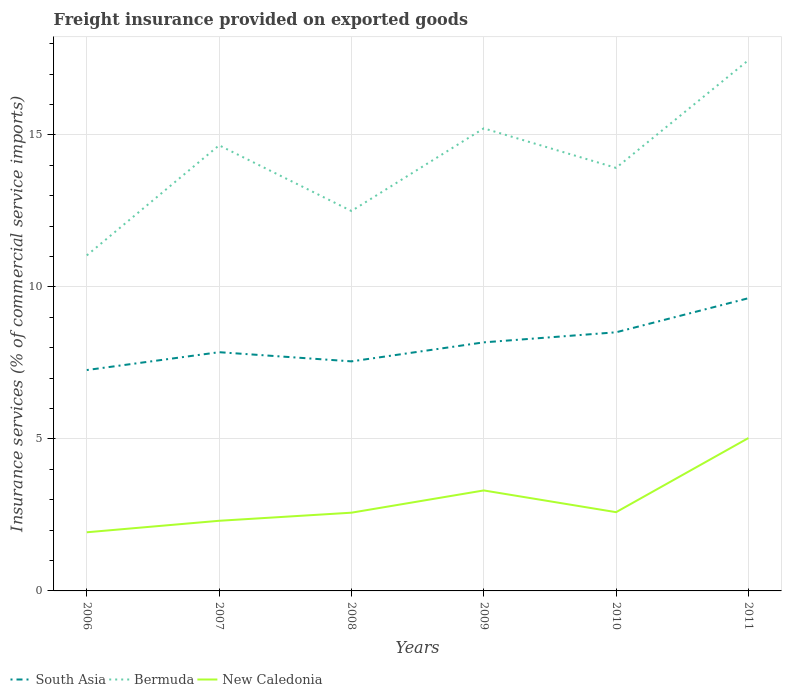Is the number of lines equal to the number of legend labels?
Your response must be concise. Yes. Across all years, what is the maximum freight insurance provided on exported goods in South Asia?
Give a very brief answer. 7.27. What is the total freight insurance provided on exported goods in Bermuda in the graph?
Give a very brief answer. -0.56. What is the difference between the highest and the second highest freight insurance provided on exported goods in South Asia?
Your response must be concise. 2.36. What is the difference between the highest and the lowest freight insurance provided on exported goods in New Caledonia?
Offer a terse response. 2. How many lines are there?
Ensure brevity in your answer.  3. What is the difference between two consecutive major ticks on the Y-axis?
Make the answer very short. 5. What is the title of the graph?
Offer a very short reply. Freight insurance provided on exported goods. Does "Turks and Caicos Islands" appear as one of the legend labels in the graph?
Ensure brevity in your answer.  No. What is the label or title of the X-axis?
Keep it short and to the point. Years. What is the label or title of the Y-axis?
Provide a short and direct response. Insurance services (% of commercial service imports). What is the Insurance services (% of commercial service imports) in South Asia in 2006?
Provide a succinct answer. 7.27. What is the Insurance services (% of commercial service imports) of Bermuda in 2006?
Your answer should be compact. 11.04. What is the Insurance services (% of commercial service imports) in New Caledonia in 2006?
Offer a terse response. 1.93. What is the Insurance services (% of commercial service imports) of South Asia in 2007?
Give a very brief answer. 7.85. What is the Insurance services (% of commercial service imports) of Bermuda in 2007?
Provide a succinct answer. 14.66. What is the Insurance services (% of commercial service imports) in New Caledonia in 2007?
Ensure brevity in your answer.  2.31. What is the Insurance services (% of commercial service imports) of South Asia in 2008?
Offer a terse response. 7.55. What is the Insurance services (% of commercial service imports) in Bermuda in 2008?
Provide a succinct answer. 12.5. What is the Insurance services (% of commercial service imports) of New Caledonia in 2008?
Your answer should be compact. 2.57. What is the Insurance services (% of commercial service imports) in South Asia in 2009?
Offer a terse response. 8.18. What is the Insurance services (% of commercial service imports) of Bermuda in 2009?
Ensure brevity in your answer.  15.22. What is the Insurance services (% of commercial service imports) of New Caledonia in 2009?
Ensure brevity in your answer.  3.31. What is the Insurance services (% of commercial service imports) of South Asia in 2010?
Provide a short and direct response. 8.51. What is the Insurance services (% of commercial service imports) in Bermuda in 2010?
Your answer should be compact. 13.91. What is the Insurance services (% of commercial service imports) in New Caledonia in 2010?
Offer a very short reply. 2.59. What is the Insurance services (% of commercial service imports) in South Asia in 2011?
Provide a short and direct response. 9.63. What is the Insurance services (% of commercial service imports) of Bermuda in 2011?
Your response must be concise. 17.46. What is the Insurance services (% of commercial service imports) of New Caledonia in 2011?
Provide a succinct answer. 5.03. Across all years, what is the maximum Insurance services (% of commercial service imports) in South Asia?
Your response must be concise. 9.63. Across all years, what is the maximum Insurance services (% of commercial service imports) in Bermuda?
Your answer should be very brief. 17.46. Across all years, what is the maximum Insurance services (% of commercial service imports) in New Caledonia?
Your answer should be compact. 5.03. Across all years, what is the minimum Insurance services (% of commercial service imports) in South Asia?
Offer a terse response. 7.27. Across all years, what is the minimum Insurance services (% of commercial service imports) of Bermuda?
Make the answer very short. 11.04. Across all years, what is the minimum Insurance services (% of commercial service imports) in New Caledonia?
Your answer should be very brief. 1.93. What is the total Insurance services (% of commercial service imports) in South Asia in the graph?
Provide a succinct answer. 48.98. What is the total Insurance services (% of commercial service imports) in Bermuda in the graph?
Your answer should be very brief. 84.78. What is the total Insurance services (% of commercial service imports) in New Caledonia in the graph?
Your answer should be very brief. 17.73. What is the difference between the Insurance services (% of commercial service imports) in South Asia in 2006 and that in 2007?
Your answer should be compact. -0.59. What is the difference between the Insurance services (% of commercial service imports) of Bermuda in 2006 and that in 2007?
Your answer should be very brief. -3.62. What is the difference between the Insurance services (% of commercial service imports) of New Caledonia in 2006 and that in 2007?
Your answer should be compact. -0.38. What is the difference between the Insurance services (% of commercial service imports) in South Asia in 2006 and that in 2008?
Your answer should be very brief. -0.29. What is the difference between the Insurance services (% of commercial service imports) of Bermuda in 2006 and that in 2008?
Your response must be concise. -1.46. What is the difference between the Insurance services (% of commercial service imports) in New Caledonia in 2006 and that in 2008?
Give a very brief answer. -0.64. What is the difference between the Insurance services (% of commercial service imports) in South Asia in 2006 and that in 2009?
Keep it short and to the point. -0.91. What is the difference between the Insurance services (% of commercial service imports) in Bermuda in 2006 and that in 2009?
Give a very brief answer. -4.18. What is the difference between the Insurance services (% of commercial service imports) of New Caledonia in 2006 and that in 2009?
Provide a succinct answer. -1.38. What is the difference between the Insurance services (% of commercial service imports) of South Asia in 2006 and that in 2010?
Offer a terse response. -1.24. What is the difference between the Insurance services (% of commercial service imports) in Bermuda in 2006 and that in 2010?
Your response must be concise. -2.88. What is the difference between the Insurance services (% of commercial service imports) of New Caledonia in 2006 and that in 2010?
Offer a terse response. -0.66. What is the difference between the Insurance services (% of commercial service imports) of South Asia in 2006 and that in 2011?
Your answer should be compact. -2.36. What is the difference between the Insurance services (% of commercial service imports) of Bermuda in 2006 and that in 2011?
Ensure brevity in your answer.  -6.42. What is the difference between the Insurance services (% of commercial service imports) of New Caledonia in 2006 and that in 2011?
Make the answer very short. -3.1. What is the difference between the Insurance services (% of commercial service imports) in South Asia in 2007 and that in 2008?
Provide a short and direct response. 0.3. What is the difference between the Insurance services (% of commercial service imports) in Bermuda in 2007 and that in 2008?
Give a very brief answer. 2.16. What is the difference between the Insurance services (% of commercial service imports) of New Caledonia in 2007 and that in 2008?
Give a very brief answer. -0.27. What is the difference between the Insurance services (% of commercial service imports) of South Asia in 2007 and that in 2009?
Give a very brief answer. -0.32. What is the difference between the Insurance services (% of commercial service imports) in Bermuda in 2007 and that in 2009?
Keep it short and to the point. -0.56. What is the difference between the Insurance services (% of commercial service imports) of New Caledonia in 2007 and that in 2009?
Your answer should be compact. -1. What is the difference between the Insurance services (% of commercial service imports) in South Asia in 2007 and that in 2010?
Offer a terse response. -0.66. What is the difference between the Insurance services (% of commercial service imports) of Bermuda in 2007 and that in 2010?
Ensure brevity in your answer.  0.74. What is the difference between the Insurance services (% of commercial service imports) of New Caledonia in 2007 and that in 2010?
Provide a succinct answer. -0.28. What is the difference between the Insurance services (% of commercial service imports) of South Asia in 2007 and that in 2011?
Make the answer very short. -1.78. What is the difference between the Insurance services (% of commercial service imports) of New Caledonia in 2007 and that in 2011?
Provide a short and direct response. -2.72. What is the difference between the Insurance services (% of commercial service imports) in South Asia in 2008 and that in 2009?
Offer a very short reply. -0.63. What is the difference between the Insurance services (% of commercial service imports) of Bermuda in 2008 and that in 2009?
Give a very brief answer. -2.72. What is the difference between the Insurance services (% of commercial service imports) in New Caledonia in 2008 and that in 2009?
Provide a succinct answer. -0.73. What is the difference between the Insurance services (% of commercial service imports) in South Asia in 2008 and that in 2010?
Your response must be concise. -0.96. What is the difference between the Insurance services (% of commercial service imports) of Bermuda in 2008 and that in 2010?
Provide a succinct answer. -1.42. What is the difference between the Insurance services (% of commercial service imports) of New Caledonia in 2008 and that in 2010?
Give a very brief answer. -0.02. What is the difference between the Insurance services (% of commercial service imports) of South Asia in 2008 and that in 2011?
Offer a terse response. -2.08. What is the difference between the Insurance services (% of commercial service imports) of Bermuda in 2008 and that in 2011?
Your answer should be compact. -4.96. What is the difference between the Insurance services (% of commercial service imports) in New Caledonia in 2008 and that in 2011?
Offer a very short reply. -2.46. What is the difference between the Insurance services (% of commercial service imports) of South Asia in 2009 and that in 2010?
Offer a very short reply. -0.33. What is the difference between the Insurance services (% of commercial service imports) in Bermuda in 2009 and that in 2010?
Your answer should be very brief. 1.3. What is the difference between the Insurance services (% of commercial service imports) of New Caledonia in 2009 and that in 2010?
Offer a terse response. 0.71. What is the difference between the Insurance services (% of commercial service imports) of South Asia in 2009 and that in 2011?
Your answer should be compact. -1.45. What is the difference between the Insurance services (% of commercial service imports) of Bermuda in 2009 and that in 2011?
Provide a succinct answer. -2.24. What is the difference between the Insurance services (% of commercial service imports) in New Caledonia in 2009 and that in 2011?
Your answer should be compact. -1.72. What is the difference between the Insurance services (% of commercial service imports) in South Asia in 2010 and that in 2011?
Provide a succinct answer. -1.12. What is the difference between the Insurance services (% of commercial service imports) of Bermuda in 2010 and that in 2011?
Offer a terse response. -3.54. What is the difference between the Insurance services (% of commercial service imports) of New Caledonia in 2010 and that in 2011?
Provide a short and direct response. -2.44. What is the difference between the Insurance services (% of commercial service imports) in South Asia in 2006 and the Insurance services (% of commercial service imports) in Bermuda in 2007?
Your answer should be compact. -7.39. What is the difference between the Insurance services (% of commercial service imports) of South Asia in 2006 and the Insurance services (% of commercial service imports) of New Caledonia in 2007?
Make the answer very short. 4.96. What is the difference between the Insurance services (% of commercial service imports) of Bermuda in 2006 and the Insurance services (% of commercial service imports) of New Caledonia in 2007?
Provide a succinct answer. 8.73. What is the difference between the Insurance services (% of commercial service imports) of South Asia in 2006 and the Insurance services (% of commercial service imports) of Bermuda in 2008?
Give a very brief answer. -5.23. What is the difference between the Insurance services (% of commercial service imports) of South Asia in 2006 and the Insurance services (% of commercial service imports) of New Caledonia in 2008?
Your answer should be compact. 4.69. What is the difference between the Insurance services (% of commercial service imports) of Bermuda in 2006 and the Insurance services (% of commercial service imports) of New Caledonia in 2008?
Give a very brief answer. 8.46. What is the difference between the Insurance services (% of commercial service imports) in South Asia in 2006 and the Insurance services (% of commercial service imports) in Bermuda in 2009?
Make the answer very short. -7.95. What is the difference between the Insurance services (% of commercial service imports) in South Asia in 2006 and the Insurance services (% of commercial service imports) in New Caledonia in 2009?
Your answer should be very brief. 3.96. What is the difference between the Insurance services (% of commercial service imports) in Bermuda in 2006 and the Insurance services (% of commercial service imports) in New Caledonia in 2009?
Your answer should be compact. 7.73. What is the difference between the Insurance services (% of commercial service imports) of South Asia in 2006 and the Insurance services (% of commercial service imports) of Bermuda in 2010?
Your answer should be compact. -6.65. What is the difference between the Insurance services (% of commercial service imports) in South Asia in 2006 and the Insurance services (% of commercial service imports) in New Caledonia in 2010?
Offer a terse response. 4.68. What is the difference between the Insurance services (% of commercial service imports) in Bermuda in 2006 and the Insurance services (% of commercial service imports) in New Caledonia in 2010?
Ensure brevity in your answer.  8.45. What is the difference between the Insurance services (% of commercial service imports) in South Asia in 2006 and the Insurance services (% of commercial service imports) in Bermuda in 2011?
Provide a short and direct response. -10.19. What is the difference between the Insurance services (% of commercial service imports) of South Asia in 2006 and the Insurance services (% of commercial service imports) of New Caledonia in 2011?
Provide a succinct answer. 2.24. What is the difference between the Insurance services (% of commercial service imports) in Bermuda in 2006 and the Insurance services (% of commercial service imports) in New Caledonia in 2011?
Make the answer very short. 6.01. What is the difference between the Insurance services (% of commercial service imports) of South Asia in 2007 and the Insurance services (% of commercial service imports) of Bermuda in 2008?
Provide a short and direct response. -4.64. What is the difference between the Insurance services (% of commercial service imports) of South Asia in 2007 and the Insurance services (% of commercial service imports) of New Caledonia in 2008?
Your answer should be very brief. 5.28. What is the difference between the Insurance services (% of commercial service imports) in Bermuda in 2007 and the Insurance services (% of commercial service imports) in New Caledonia in 2008?
Provide a short and direct response. 12.08. What is the difference between the Insurance services (% of commercial service imports) in South Asia in 2007 and the Insurance services (% of commercial service imports) in Bermuda in 2009?
Make the answer very short. -7.36. What is the difference between the Insurance services (% of commercial service imports) of South Asia in 2007 and the Insurance services (% of commercial service imports) of New Caledonia in 2009?
Your answer should be compact. 4.55. What is the difference between the Insurance services (% of commercial service imports) of Bermuda in 2007 and the Insurance services (% of commercial service imports) of New Caledonia in 2009?
Provide a succinct answer. 11.35. What is the difference between the Insurance services (% of commercial service imports) of South Asia in 2007 and the Insurance services (% of commercial service imports) of Bermuda in 2010?
Keep it short and to the point. -6.06. What is the difference between the Insurance services (% of commercial service imports) of South Asia in 2007 and the Insurance services (% of commercial service imports) of New Caledonia in 2010?
Offer a terse response. 5.26. What is the difference between the Insurance services (% of commercial service imports) of Bermuda in 2007 and the Insurance services (% of commercial service imports) of New Caledonia in 2010?
Keep it short and to the point. 12.07. What is the difference between the Insurance services (% of commercial service imports) of South Asia in 2007 and the Insurance services (% of commercial service imports) of Bermuda in 2011?
Your answer should be compact. -9.61. What is the difference between the Insurance services (% of commercial service imports) of South Asia in 2007 and the Insurance services (% of commercial service imports) of New Caledonia in 2011?
Offer a terse response. 2.82. What is the difference between the Insurance services (% of commercial service imports) of Bermuda in 2007 and the Insurance services (% of commercial service imports) of New Caledonia in 2011?
Your answer should be compact. 9.63. What is the difference between the Insurance services (% of commercial service imports) of South Asia in 2008 and the Insurance services (% of commercial service imports) of Bermuda in 2009?
Offer a terse response. -7.66. What is the difference between the Insurance services (% of commercial service imports) in South Asia in 2008 and the Insurance services (% of commercial service imports) in New Caledonia in 2009?
Give a very brief answer. 4.25. What is the difference between the Insurance services (% of commercial service imports) in Bermuda in 2008 and the Insurance services (% of commercial service imports) in New Caledonia in 2009?
Your answer should be very brief. 9.19. What is the difference between the Insurance services (% of commercial service imports) of South Asia in 2008 and the Insurance services (% of commercial service imports) of Bermuda in 2010?
Ensure brevity in your answer.  -6.36. What is the difference between the Insurance services (% of commercial service imports) of South Asia in 2008 and the Insurance services (% of commercial service imports) of New Caledonia in 2010?
Your response must be concise. 4.96. What is the difference between the Insurance services (% of commercial service imports) in Bermuda in 2008 and the Insurance services (% of commercial service imports) in New Caledonia in 2010?
Offer a very short reply. 9.91. What is the difference between the Insurance services (% of commercial service imports) in South Asia in 2008 and the Insurance services (% of commercial service imports) in Bermuda in 2011?
Give a very brief answer. -9.91. What is the difference between the Insurance services (% of commercial service imports) of South Asia in 2008 and the Insurance services (% of commercial service imports) of New Caledonia in 2011?
Your answer should be compact. 2.52. What is the difference between the Insurance services (% of commercial service imports) of Bermuda in 2008 and the Insurance services (% of commercial service imports) of New Caledonia in 2011?
Give a very brief answer. 7.47. What is the difference between the Insurance services (% of commercial service imports) of South Asia in 2009 and the Insurance services (% of commercial service imports) of Bermuda in 2010?
Your answer should be compact. -5.74. What is the difference between the Insurance services (% of commercial service imports) in South Asia in 2009 and the Insurance services (% of commercial service imports) in New Caledonia in 2010?
Ensure brevity in your answer.  5.59. What is the difference between the Insurance services (% of commercial service imports) in Bermuda in 2009 and the Insurance services (% of commercial service imports) in New Caledonia in 2010?
Offer a very short reply. 12.63. What is the difference between the Insurance services (% of commercial service imports) of South Asia in 2009 and the Insurance services (% of commercial service imports) of Bermuda in 2011?
Your response must be concise. -9.28. What is the difference between the Insurance services (% of commercial service imports) of South Asia in 2009 and the Insurance services (% of commercial service imports) of New Caledonia in 2011?
Provide a short and direct response. 3.15. What is the difference between the Insurance services (% of commercial service imports) in Bermuda in 2009 and the Insurance services (% of commercial service imports) in New Caledonia in 2011?
Give a very brief answer. 10.19. What is the difference between the Insurance services (% of commercial service imports) of South Asia in 2010 and the Insurance services (% of commercial service imports) of Bermuda in 2011?
Provide a short and direct response. -8.95. What is the difference between the Insurance services (% of commercial service imports) of South Asia in 2010 and the Insurance services (% of commercial service imports) of New Caledonia in 2011?
Offer a terse response. 3.48. What is the difference between the Insurance services (% of commercial service imports) in Bermuda in 2010 and the Insurance services (% of commercial service imports) in New Caledonia in 2011?
Provide a succinct answer. 8.89. What is the average Insurance services (% of commercial service imports) in South Asia per year?
Provide a succinct answer. 8.16. What is the average Insurance services (% of commercial service imports) in Bermuda per year?
Ensure brevity in your answer.  14.13. What is the average Insurance services (% of commercial service imports) of New Caledonia per year?
Make the answer very short. 2.96. In the year 2006, what is the difference between the Insurance services (% of commercial service imports) in South Asia and Insurance services (% of commercial service imports) in Bermuda?
Make the answer very short. -3.77. In the year 2006, what is the difference between the Insurance services (% of commercial service imports) in South Asia and Insurance services (% of commercial service imports) in New Caledonia?
Provide a short and direct response. 5.34. In the year 2006, what is the difference between the Insurance services (% of commercial service imports) in Bermuda and Insurance services (% of commercial service imports) in New Caledonia?
Your answer should be very brief. 9.11. In the year 2007, what is the difference between the Insurance services (% of commercial service imports) of South Asia and Insurance services (% of commercial service imports) of Bermuda?
Ensure brevity in your answer.  -6.81. In the year 2007, what is the difference between the Insurance services (% of commercial service imports) in South Asia and Insurance services (% of commercial service imports) in New Caledonia?
Ensure brevity in your answer.  5.55. In the year 2007, what is the difference between the Insurance services (% of commercial service imports) of Bermuda and Insurance services (% of commercial service imports) of New Caledonia?
Offer a very short reply. 12.35. In the year 2008, what is the difference between the Insurance services (% of commercial service imports) in South Asia and Insurance services (% of commercial service imports) in Bermuda?
Provide a succinct answer. -4.95. In the year 2008, what is the difference between the Insurance services (% of commercial service imports) in South Asia and Insurance services (% of commercial service imports) in New Caledonia?
Make the answer very short. 4.98. In the year 2008, what is the difference between the Insurance services (% of commercial service imports) in Bermuda and Insurance services (% of commercial service imports) in New Caledonia?
Make the answer very short. 9.92. In the year 2009, what is the difference between the Insurance services (% of commercial service imports) in South Asia and Insurance services (% of commercial service imports) in Bermuda?
Offer a very short reply. -7.04. In the year 2009, what is the difference between the Insurance services (% of commercial service imports) of South Asia and Insurance services (% of commercial service imports) of New Caledonia?
Keep it short and to the point. 4.87. In the year 2009, what is the difference between the Insurance services (% of commercial service imports) in Bermuda and Insurance services (% of commercial service imports) in New Caledonia?
Make the answer very short. 11.91. In the year 2010, what is the difference between the Insurance services (% of commercial service imports) in South Asia and Insurance services (% of commercial service imports) in Bermuda?
Your answer should be compact. -5.41. In the year 2010, what is the difference between the Insurance services (% of commercial service imports) of South Asia and Insurance services (% of commercial service imports) of New Caledonia?
Provide a succinct answer. 5.92. In the year 2010, what is the difference between the Insurance services (% of commercial service imports) in Bermuda and Insurance services (% of commercial service imports) in New Caledonia?
Offer a very short reply. 11.32. In the year 2011, what is the difference between the Insurance services (% of commercial service imports) in South Asia and Insurance services (% of commercial service imports) in Bermuda?
Provide a succinct answer. -7.83. In the year 2011, what is the difference between the Insurance services (% of commercial service imports) in South Asia and Insurance services (% of commercial service imports) in New Caledonia?
Give a very brief answer. 4.6. In the year 2011, what is the difference between the Insurance services (% of commercial service imports) of Bermuda and Insurance services (% of commercial service imports) of New Caledonia?
Provide a short and direct response. 12.43. What is the ratio of the Insurance services (% of commercial service imports) of South Asia in 2006 to that in 2007?
Ensure brevity in your answer.  0.93. What is the ratio of the Insurance services (% of commercial service imports) in Bermuda in 2006 to that in 2007?
Your response must be concise. 0.75. What is the ratio of the Insurance services (% of commercial service imports) in New Caledonia in 2006 to that in 2007?
Offer a very short reply. 0.84. What is the ratio of the Insurance services (% of commercial service imports) in South Asia in 2006 to that in 2008?
Offer a very short reply. 0.96. What is the ratio of the Insurance services (% of commercial service imports) of Bermuda in 2006 to that in 2008?
Make the answer very short. 0.88. What is the ratio of the Insurance services (% of commercial service imports) of New Caledonia in 2006 to that in 2008?
Keep it short and to the point. 0.75. What is the ratio of the Insurance services (% of commercial service imports) of South Asia in 2006 to that in 2009?
Make the answer very short. 0.89. What is the ratio of the Insurance services (% of commercial service imports) of Bermuda in 2006 to that in 2009?
Your answer should be compact. 0.73. What is the ratio of the Insurance services (% of commercial service imports) of New Caledonia in 2006 to that in 2009?
Provide a succinct answer. 0.58. What is the ratio of the Insurance services (% of commercial service imports) in South Asia in 2006 to that in 2010?
Provide a succinct answer. 0.85. What is the ratio of the Insurance services (% of commercial service imports) of Bermuda in 2006 to that in 2010?
Your answer should be compact. 0.79. What is the ratio of the Insurance services (% of commercial service imports) of New Caledonia in 2006 to that in 2010?
Offer a terse response. 0.74. What is the ratio of the Insurance services (% of commercial service imports) of South Asia in 2006 to that in 2011?
Give a very brief answer. 0.75. What is the ratio of the Insurance services (% of commercial service imports) in Bermuda in 2006 to that in 2011?
Ensure brevity in your answer.  0.63. What is the ratio of the Insurance services (% of commercial service imports) in New Caledonia in 2006 to that in 2011?
Provide a short and direct response. 0.38. What is the ratio of the Insurance services (% of commercial service imports) in South Asia in 2007 to that in 2008?
Offer a very short reply. 1.04. What is the ratio of the Insurance services (% of commercial service imports) of Bermuda in 2007 to that in 2008?
Your answer should be compact. 1.17. What is the ratio of the Insurance services (% of commercial service imports) in New Caledonia in 2007 to that in 2008?
Your response must be concise. 0.9. What is the ratio of the Insurance services (% of commercial service imports) in South Asia in 2007 to that in 2009?
Your response must be concise. 0.96. What is the ratio of the Insurance services (% of commercial service imports) of Bermuda in 2007 to that in 2009?
Offer a terse response. 0.96. What is the ratio of the Insurance services (% of commercial service imports) of New Caledonia in 2007 to that in 2009?
Give a very brief answer. 0.7. What is the ratio of the Insurance services (% of commercial service imports) in South Asia in 2007 to that in 2010?
Ensure brevity in your answer.  0.92. What is the ratio of the Insurance services (% of commercial service imports) in Bermuda in 2007 to that in 2010?
Give a very brief answer. 1.05. What is the ratio of the Insurance services (% of commercial service imports) in New Caledonia in 2007 to that in 2010?
Provide a succinct answer. 0.89. What is the ratio of the Insurance services (% of commercial service imports) of South Asia in 2007 to that in 2011?
Provide a short and direct response. 0.82. What is the ratio of the Insurance services (% of commercial service imports) of Bermuda in 2007 to that in 2011?
Give a very brief answer. 0.84. What is the ratio of the Insurance services (% of commercial service imports) of New Caledonia in 2007 to that in 2011?
Provide a succinct answer. 0.46. What is the ratio of the Insurance services (% of commercial service imports) of South Asia in 2008 to that in 2009?
Offer a very short reply. 0.92. What is the ratio of the Insurance services (% of commercial service imports) in Bermuda in 2008 to that in 2009?
Give a very brief answer. 0.82. What is the ratio of the Insurance services (% of commercial service imports) of New Caledonia in 2008 to that in 2009?
Offer a very short reply. 0.78. What is the ratio of the Insurance services (% of commercial service imports) in South Asia in 2008 to that in 2010?
Your response must be concise. 0.89. What is the ratio of the Insurance services (% of commercial service imports) in Bermuda in 2008 to that in 2010?
Offer a terse response. 0.9. What is the ratio of the Insurance services (% of commercial service imports) of New Caledonia in 2008 to that in 2010?
Your answer should be compact. 0.99. What is the ratio of the Insurance services (% of commercial service imports) of South Asia in 2008 to that in 2011?
Provide a succinct answer. 0.78. What is the ratio of the Insurance services (% of commercial service imports) of Bermuda in 2008 to that in 2011?
Offer a terse response. 0.72. What is the ratio of the Insurance services (% of commercial service imports) of New Caledonia in 2008 to that in 2011?
Offer a very short reply. 0.51. What is the ratio of the Insurance services (% of commercial service imports) of South Asia in 2009 to that in 2010?
Keep it short and to the point. 0.96. What is the ratio of the Insurance services (% of commercial service imports) in Bermuda in 2009 to that in 2010?
Offer a terse response. 1.09. What is the ratio of the Insurance services (% of commercial service imports) of New Caledonia in 2009 to that in 2010?
Your answer should be very brief. 1.28. What is the ratio of the Insurance services (% of commercial service imports) of South Asia in 2009 to that in 2011?
Your response must be concise. 0.85. What is the ratio of the Insurance services (% of commercial service imports) of Bermuda in 2009 to that in 2011?
Make the answer very short. 0.87. What is the ratio of the Insurance services (% of commercial service imports) of New Caledonia in 2009 to that in 2011?
Give a very brief answer. 0.66. What is the ratio of the Insurance services (% of commercial service imports) in South Asia in 2010 to that in 2011?
Your answer should be very brief. 0.88. What is the ratio of the Insurance services (% of commercial service imports) in Bermuda in 2010 to that in 2011?
Keep it short and to the point. 0.8. What is the ratio of the Insurance services (% of commercial service imports) in New Caledonia in 2010 to that in 2011?
Keep it short and to the point. 0.52. What is the difference between the highest and the second highest Insurance services (% of commercial service imports) in South Asia?
Provide a succinct answer. 1.12. What is the difference between the highest and the second highest Insurance services (% of commercial service imports) in Bermuda?
Offer a terse response. 2.24. What is the difference between the highest and the second highest Insurance services (% of commercial service imports) of New Caledonia?
Keep it short and to the point. 1.72. What is the difference between the highest and the lowest Insurance services (% of commercial service imports) in South Asia?
Offer a very short reply. 2.36. What is the difference between the highest and the lowest Insurance services (% of commercial service imports) of Bermuda?
Your answer should be very brief. 6.42. What is the difference between the highest and the lowest Insurance services (% of commercial service imports) of New Caledonia?
Offer a very short reply. 3.1. 